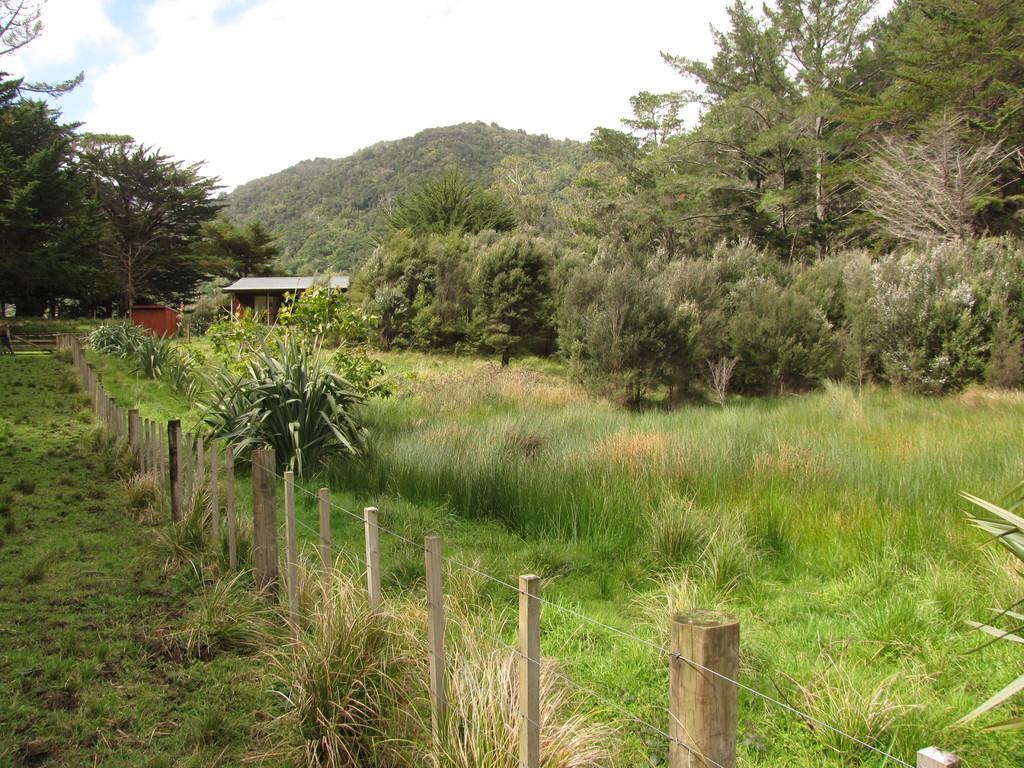Please provide a concise description of this image. In this picture we can see a fence, grass and plants on the ground, here we can see sheds, trees and some objects and in the background we can see sky with clouds. 